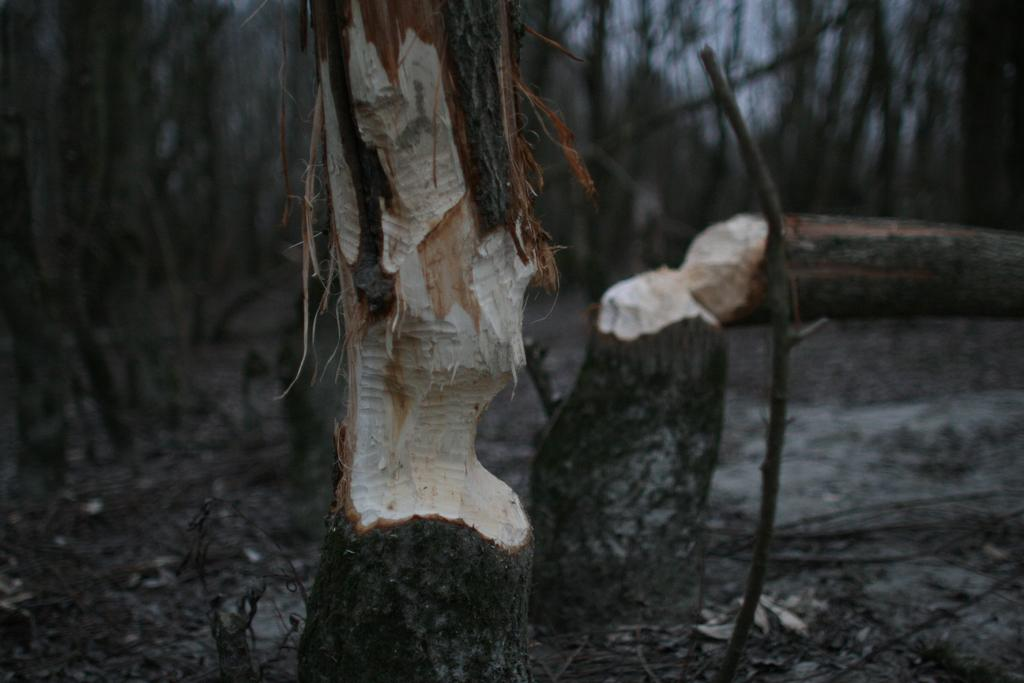What objects are present in the image? There are chopped tree trunks in the image. Can you describe the background of the image? The background of the image is blurred. What type of gate can be seen in the image? There is no gate present in the image; it only features chopped tree trunks and a blurred background. 